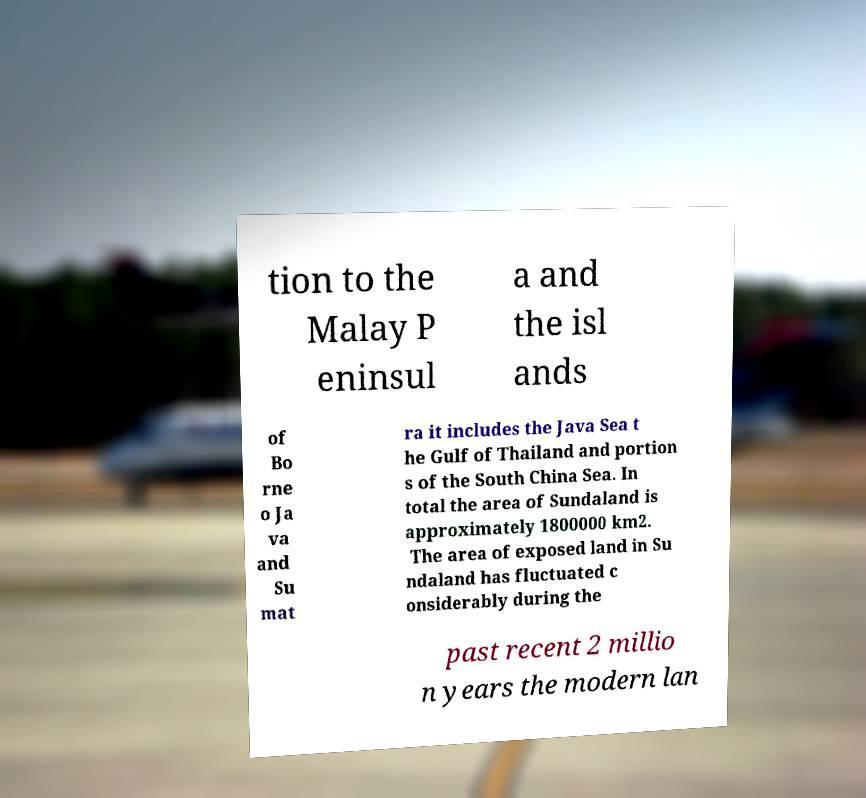Can you read and provide the text displayed in the image?This photo seems to have some interesting text. Can you extract and type it out for me? tion to the Malay P eninsul a and the isl ands of Bo rne o Ja va and Su mat ra it includes the Java Sea t he Gulf of Thailand and portion s of the South China Sea. In total the area of Sundaland is approximately 1800000 km2. The area of exposed land in Su ndaland has fluctuated c onsiderably during the past recent 2 millio n years the modern lan 